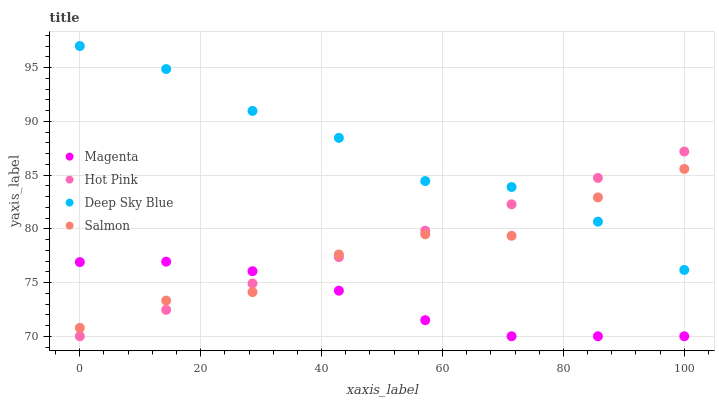Does Magenta have the minimum area under the curve?
Answer yes or no. Yes. Does Deep Sky Blue have the maximum area under the curve?
Answer yes or no. Yes. Does Hot Pink have the minimum area under the curve?
Answer yes or no. No. Does Hot Pink have the maximum area under the curve?
Answer yes or no. No. Is Hot Pink the smoothest?
Answer yes or no. Yes. Is Salmon the roughest?
Answer yes or no. Yes. Is Salmon the smoothest?
Answer yes or no. No. Is Hot Pink the roughest?
Answer yes or no. No. Does Magenta have the lowest value?
Answer yes or no. Yes. Does Salmon have the lowest value?
Answer yes or no. No. Does Deep Sky Blue have the highest value?
Answer yes or no. Yes. Does Hot Pink have the highest value?
Answer yes or no. No. Is Magenta less than Deep Sky Blue?
Answer yes or no. Yes. Is Deep Sky Blue greater than Magenta?
Answer yes or no. Yes. Does Salmon intersect Deep Sky Blue?
Answer yes or no. Yes. Is Salmon less than Deep Sky Blue?
Answer yes or no. No. Is Salmon greater than Deep Sky Blue?
Answer yes or no. No. Does Magenta intersect Deep Sky Blue?
Answer yes or no. No. 